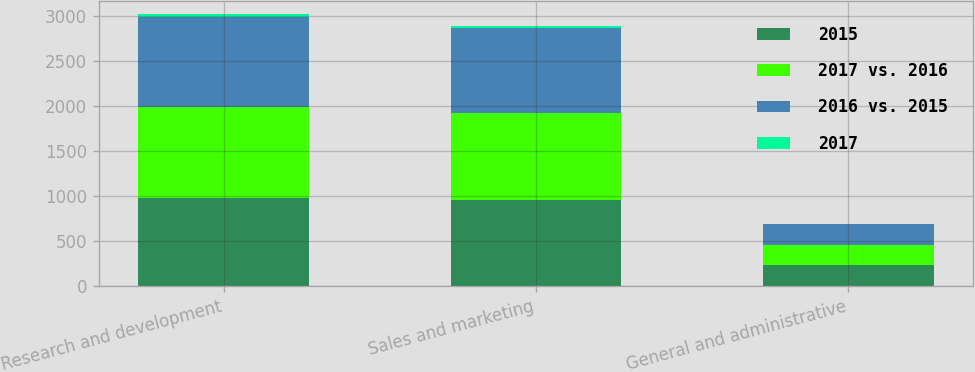Convert chart. <chart><loc_0><loc_0><loc_500><loc_500><stacked_bar_chart><ecel><fcel>Research and development<fcel>Sales and marketing<fcel>General and administrative<nl><fcel>2015<fcel>980.7<fcel>950.2<fcel>227.5<nl><fcel>2017 vs. 2016<fcel>1013.7<fcel>972.9<fcel>224.9<nl><fcel>2016 vs. 2015<fcel>994.5<fcel>943.8<fcel>228.9<nl><fcel>2017<fcel>33<fcel>22.7<fcel>2.6<nl></chart> 